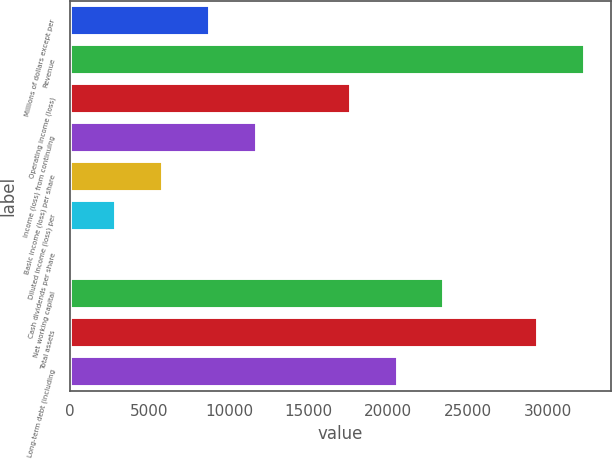Convert chart to OTSL. <chart><loc_0><loc_0><loc_500><loc_500><bar_chart><fcel>Millions of dollars except per<fcel>Revenue<fcel>Operating income (loss)<fcel>Income (loss) from continuing<fcel>Basic income (loss) per share<fcel>Diluted income (loss) per<fcel>Cash dividends per share<fcel>Net working capital<fcel>Total assets<fcel>Long-term debt (including<nl><fcel>8820.98<fcel>32342.2<fcel>17641.4<fcel>11761.1<fcel>5880.83<fcel>2940.68<fcel>0.53<fcel>23521.7<fcel>29402<fcel>20581.6<nl></chart> 